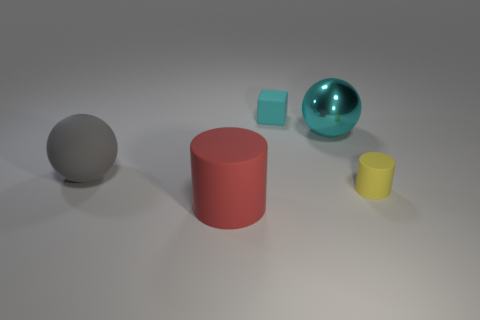Is there any other thing that is the same shape as the tiny cyan object?
Ensure brevity in your answer.  No. What shape is the tiny cyan object behind the matte thing on the right side of the big cyan thing?
Give a very brief answer. Cube. There is a red cylinder; is it the same size as the cube that is behind the yellow matte object?
Keep it short and to the point. No. What size is the cylinder left of the small thing to the right of the big ball right of the big gray ball?
Give a very brief answer. Large. What number of things are either objects behind the big rubber sphere or cyan rubber cubes?
Give a very brief answer. 2. There is a shiny thing that is right of the large gray thing; what number of small rubber things are to the left of it?
Your answer should be very brief. 1. Are there more rubber things in front of the cyan cube than gray matte objects?
Make the answer very short. Yes. How big is the rubber thing that is in front of the big shiny thing and right of the red matte cylinder?
Your answer should be very brief. Small. What shape is the big thing that is both on the right side of the big matte ball and on the left side of the big cyan metallic thing?
Provide a short and direct response. Cylinder. Are there any big balls that are right of the matte cylinder that is on the left side of the sphere to the right of the small cyan object?
Ensure brevity in your answer.  Yes. 